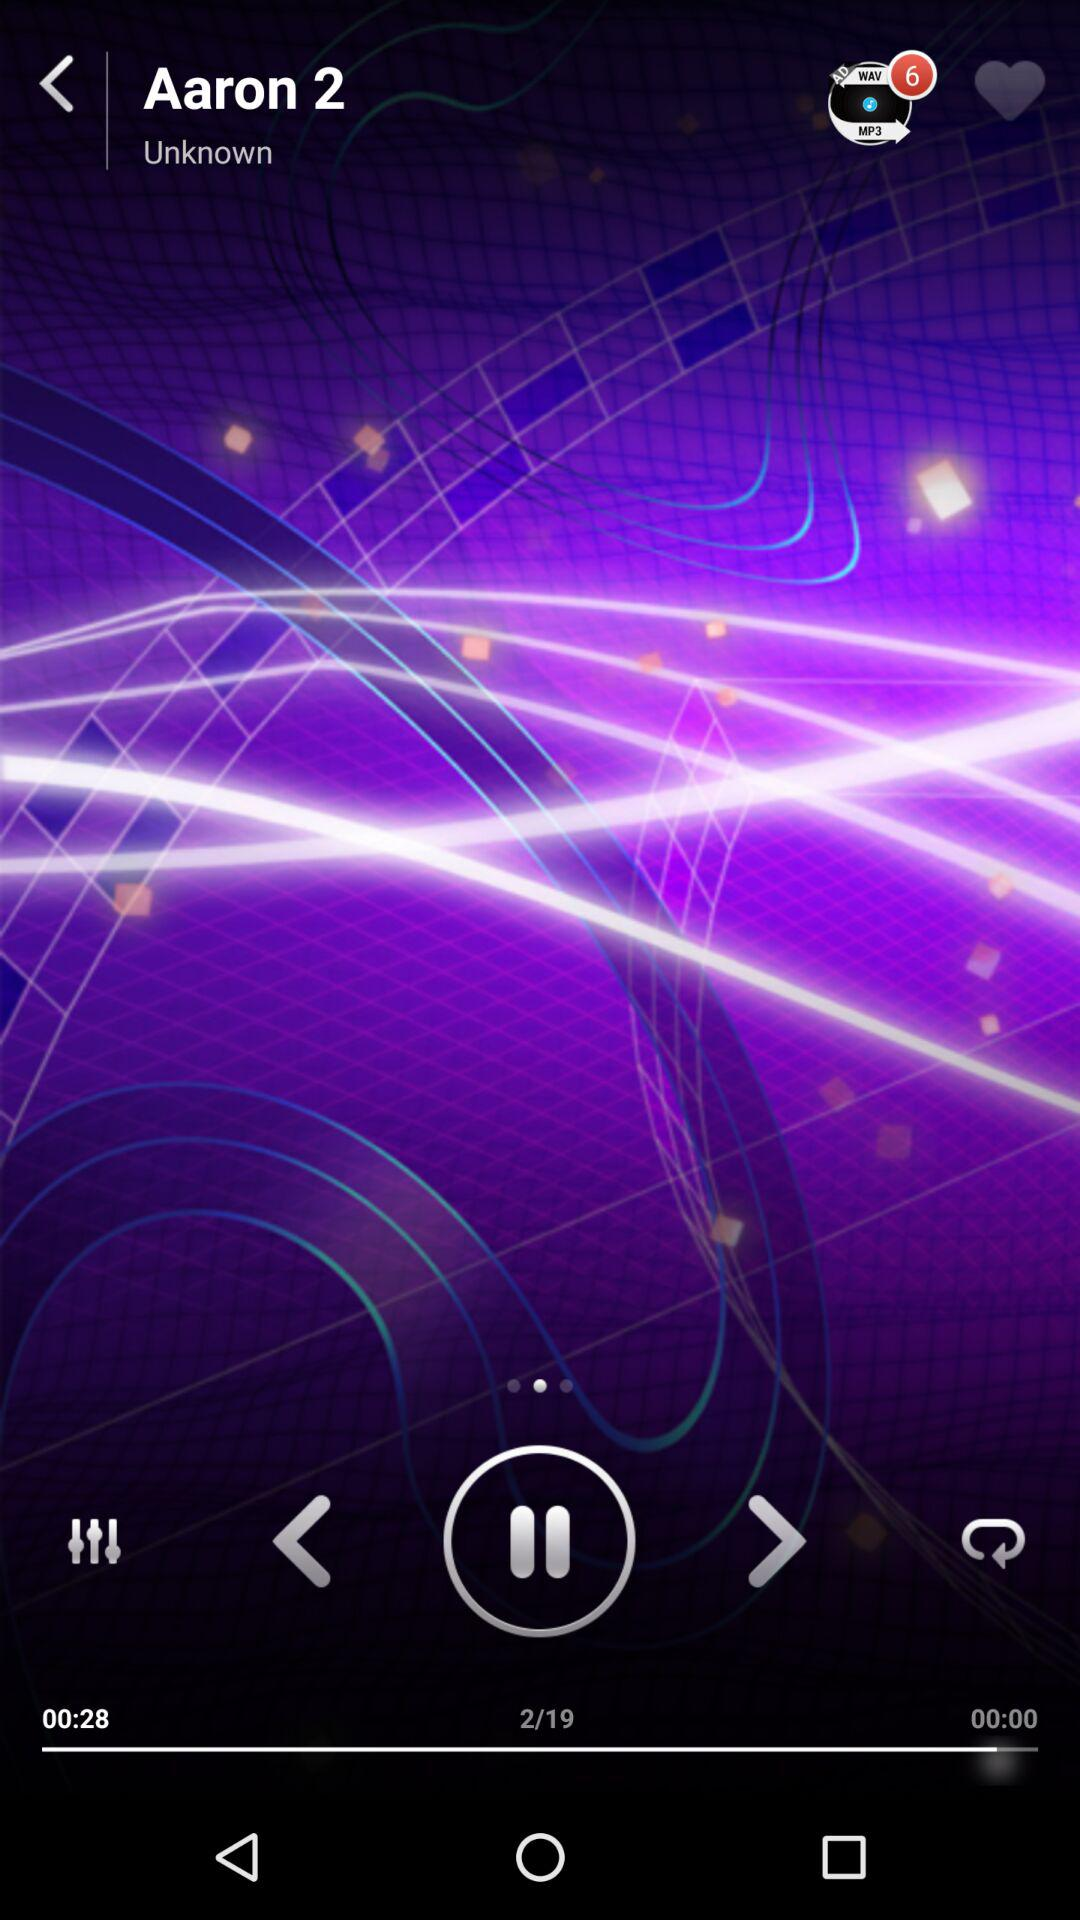What is the name of the song? The song name is "Aaron 2". 